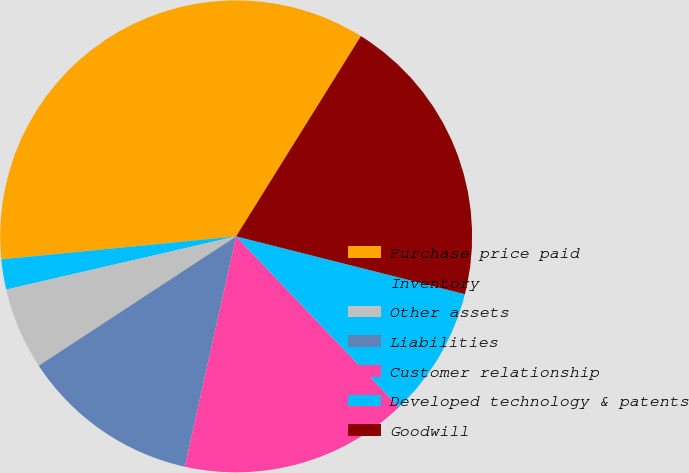Convert chart to OTSL. <chart><loc_0><loc_0><loc_500><loc_500><pie_chart><fcel>Purchase price paid<fcel>Inventory<fcel>Other assets<fcel>Liabilities<fcel>Customer relationship<fcel>Developed technology & patents<fcel>Goodwill<nl><fcel>35.42%<fcel>2.07%<fcel>5.61%<fcel>12.28%<fcel>15.61%<fcel>8.94%<fcel>20.07%<nl></chart> 